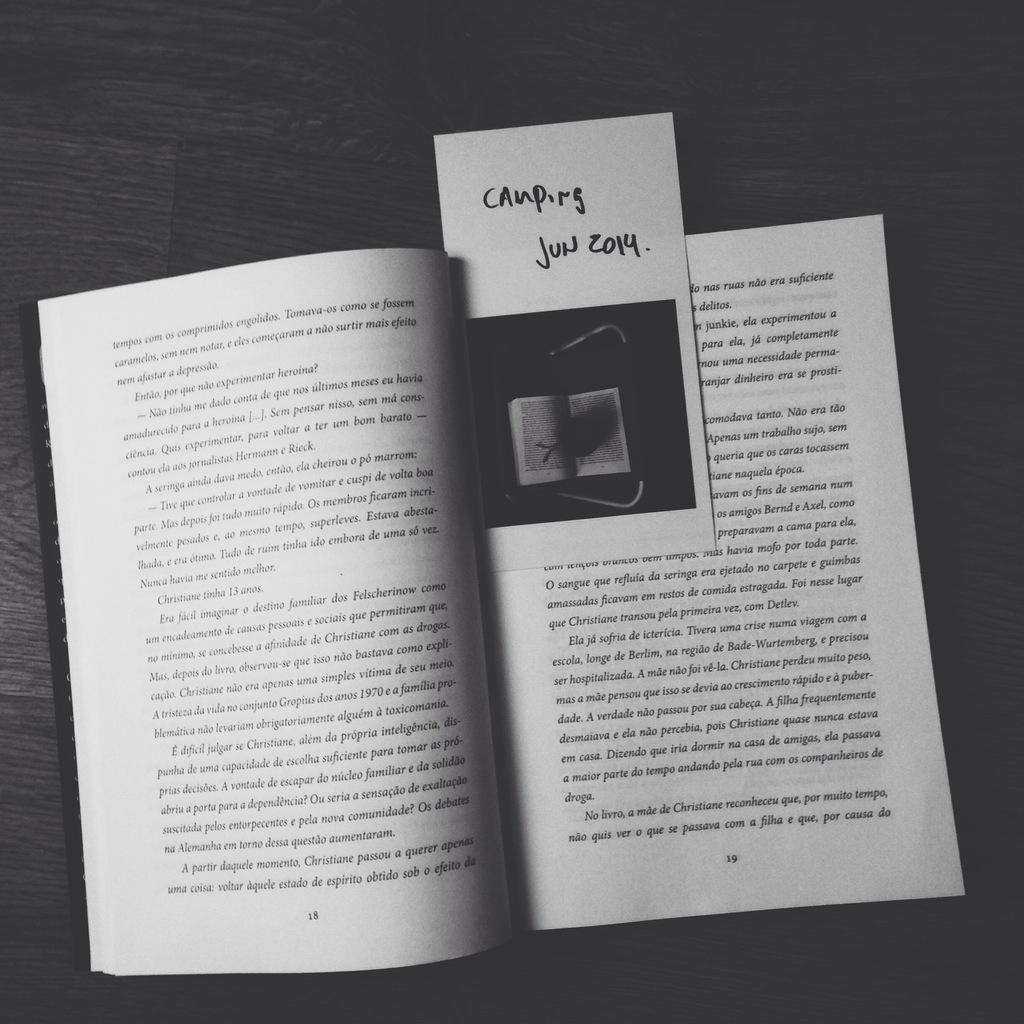<image>
Create a compact narrative representing the image presented. the book has a book mark showing 'Camping Jun 2014' 